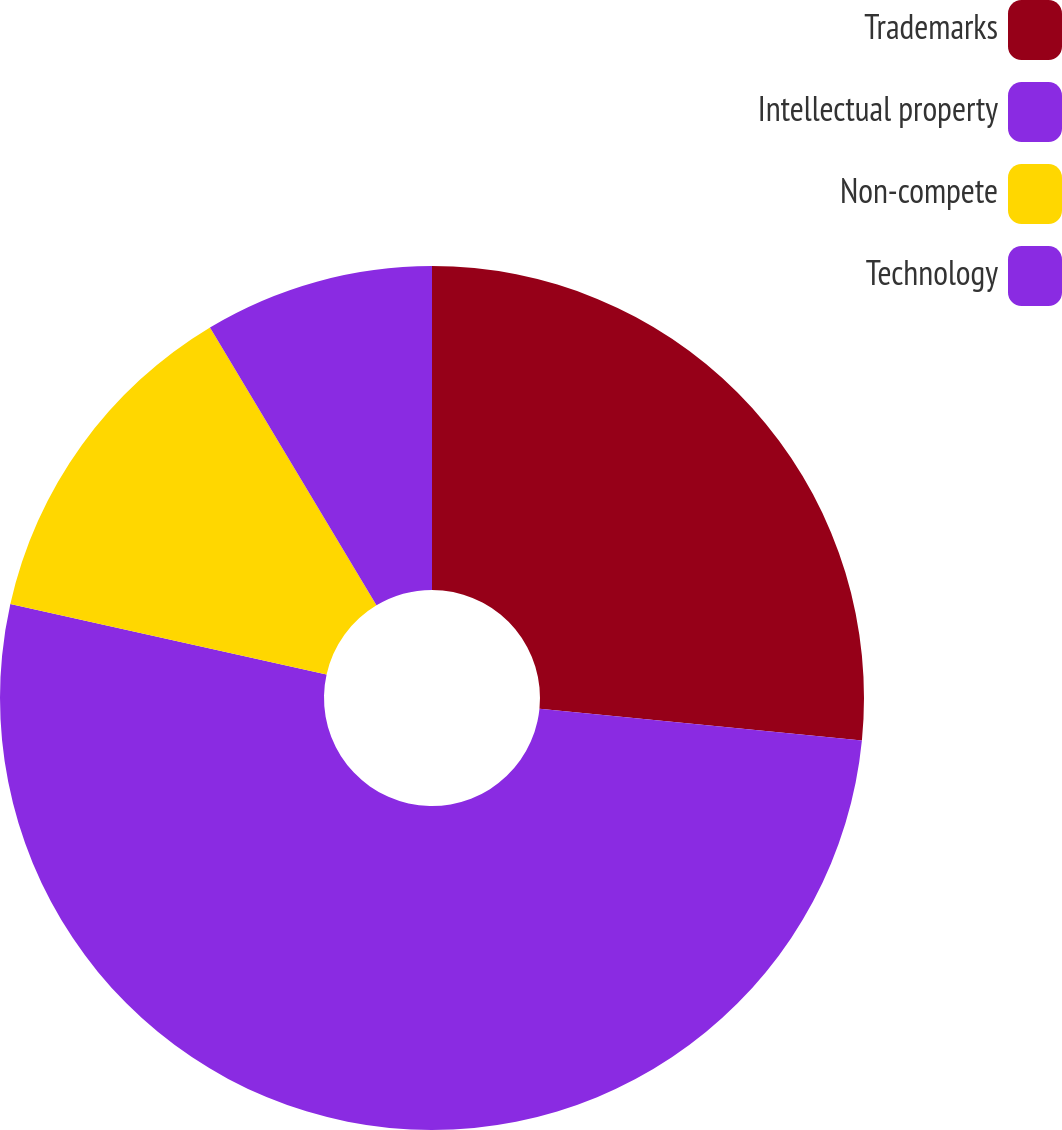<chart> <loc_0><loc_0><loc_500><loc_500><pie_chart><fcel>Trademarks<fcel>Intellectual property<fcel>Non-compete<fcel>Technology<nl><fcel>26.57%<fcel>51.92%<fcel>12.92%<fcel>8.59%<nl></chart> 